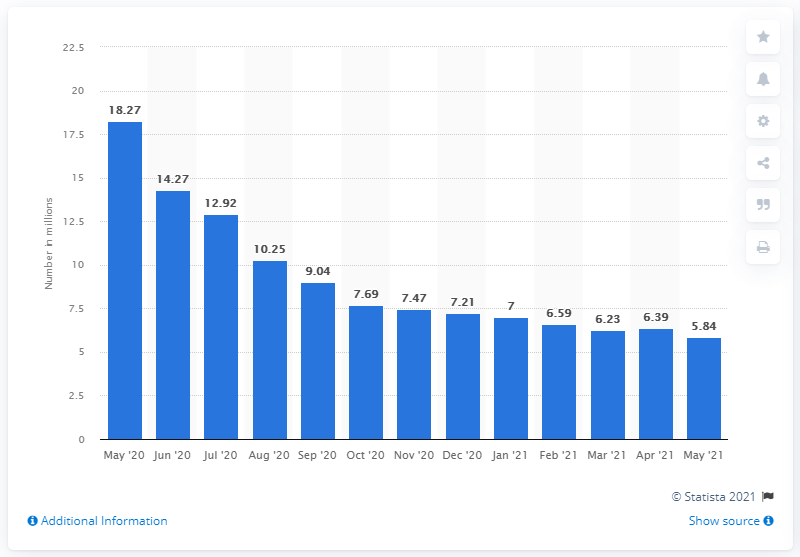Point out several critical features in this image. In May 2021, there were a total of 5.84 million job losers and individuals who completed temporary jobs in the United States. 